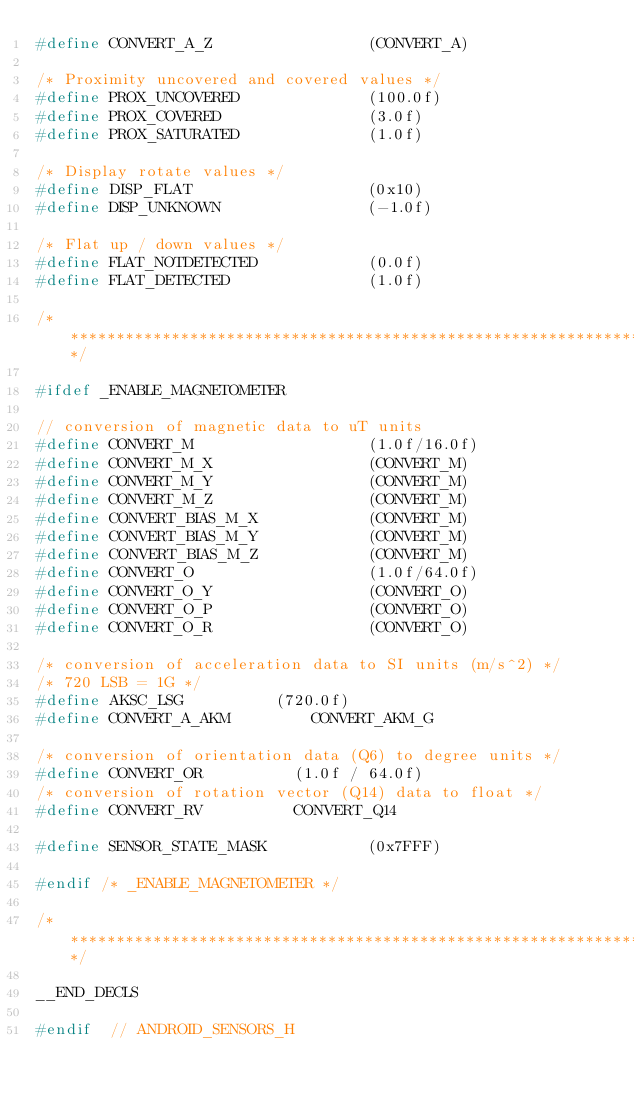<code> <loc_0><loc_0><loc_500><loc_500><_C_>#define CONVERT_A_Z                 (CONVERT_A)

/* Proximity uncovered and covered values */
#define PROX_UNCOVERED              (100.0f)
#define PROX_COVERED                (3.0f)
#define PROX_SATURATED              (1.0f)

/* Display rotate values */
#define DISP_FLAT                   (0x10)
#define DISP_UNKNOWN                (-1.0f)

/* Flat up / down values */
#define FLAT_NOTDETECTED            (0.0f)
#define FLAT_DETECTED               (1.0f)

/*****************************************************************************/

#ifdef _ENABLE_MAGNETOMETER

// conversion of magnetic data to uT units
#define CONVERT_M                   (1.0f/16.0f)
#define CONVERT_M_X                 (CONVERT_M)
#define CONVERT_M_Y                 (CONVERT_M)
#define CONVERT_M_Z                 (CONVERT_M)
#define CONVERT_BIAS_M_X            (CONVERT_M)
#define CONVERT_BIAS_M_Y            (CONVERT_M)
#define CONVERT_BIAS_M_Z            (CONVERT_M)
#define CONVERT_O                   (1.0f/64.0f)
#define CONVERT_O_Y                 (CONVERT_O)
#define CONVERT_O_P                 (CONVERT_O)
#define CONVERT_O_R                 (CONVERT_O)

/* conversion of acceleration data to SI units (m/s^2) */
/* 720 LSB = 1G */
#define AKSC_LSG					(720.0f)
#define CONVERT_A_AKM					CONVERT_AKM_G

/* conversion of orientation data (Q6) to degree units */
#define CONVERT_OR					(1.0f / 64.0f)
/* conversion of rotation vector (Q14) data to float */
#define CONVERT_RV					CONVERT_Q14

#define SENSOR_STATE_MASK           (0x7FFF)

#endif /* _ENABLE_MAGNETOMETER */

/*****************************************************************************/

__END_DECLS

#endif  // ANDROID_SENSORS_H
</code> 